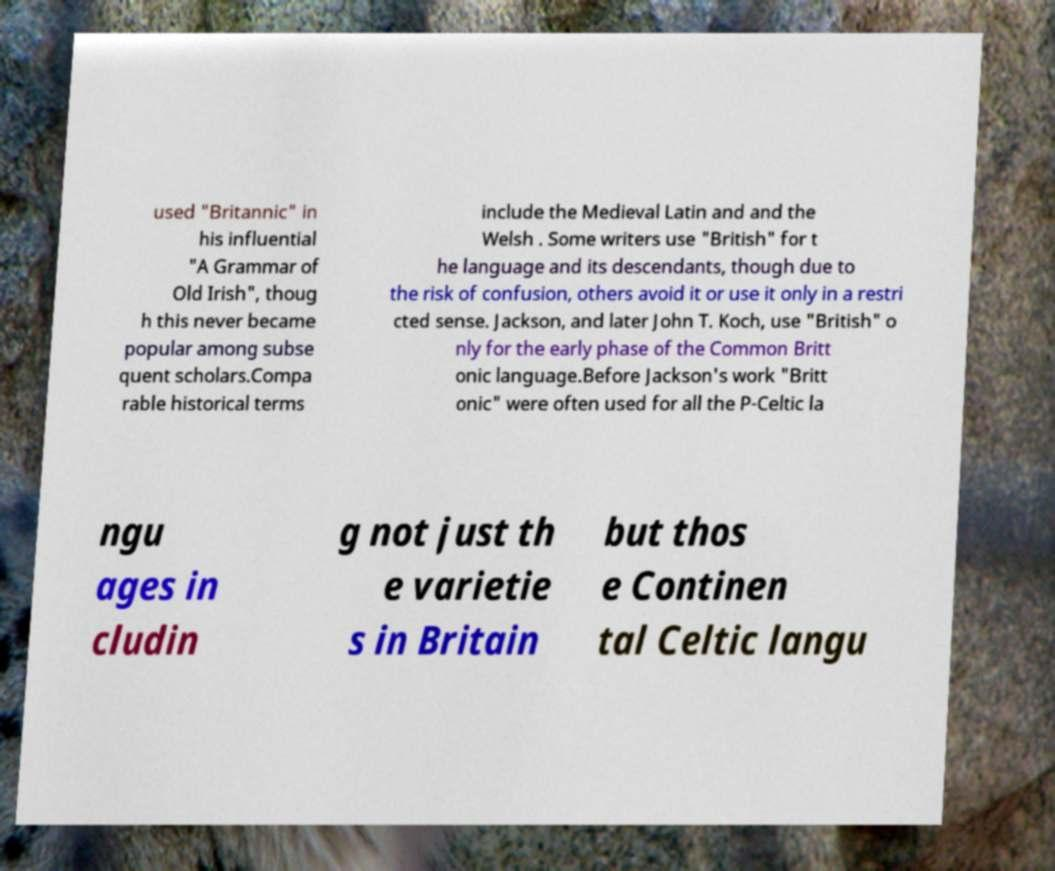For documentation purposes, I need the text within this image transcribed. Could you provide that? used "Britannic" in his influential "A Grammar of Old Irish", thoug h this never became popular among subse quent scholars.Compa rable historical terms include the Medieval Latin and and the Welsh . Some writers use "British" for t he language and its descendants, though due to the risk of confusion, others avoid it or use it only in a restri cted sense. Jackson, and later John T. Koch, use "British" o nly for the early phase of the Common Britt onic language.Before Jackson's work "Britt onic" were often used for all the P-Celtic la ngu ages in cludin g not just th e varietie s in Britain but thos e Continen tal Celtic langu 